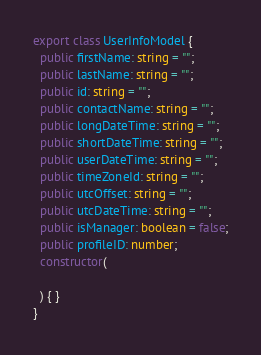Convert code to text. <code><loc_0><loc_0><loc_500><loc_500><_TypeScript_>export class UserInfoModel {
  public firstName: string = "";
  public lastName: string = "";
  public id: string = "";
  public contactName: string = "";
  public longDateTime: string = "";
  public shortDateTime: string = "";
  public userDateTime: string = "";
  public timeZoneId: string = "";
  public utcOffset: string = "";
  public utcDateTime: string = "";
  public isManager: boolean = false;
  public profileID: number;
  constructor(

  ) { }
}

</code> 